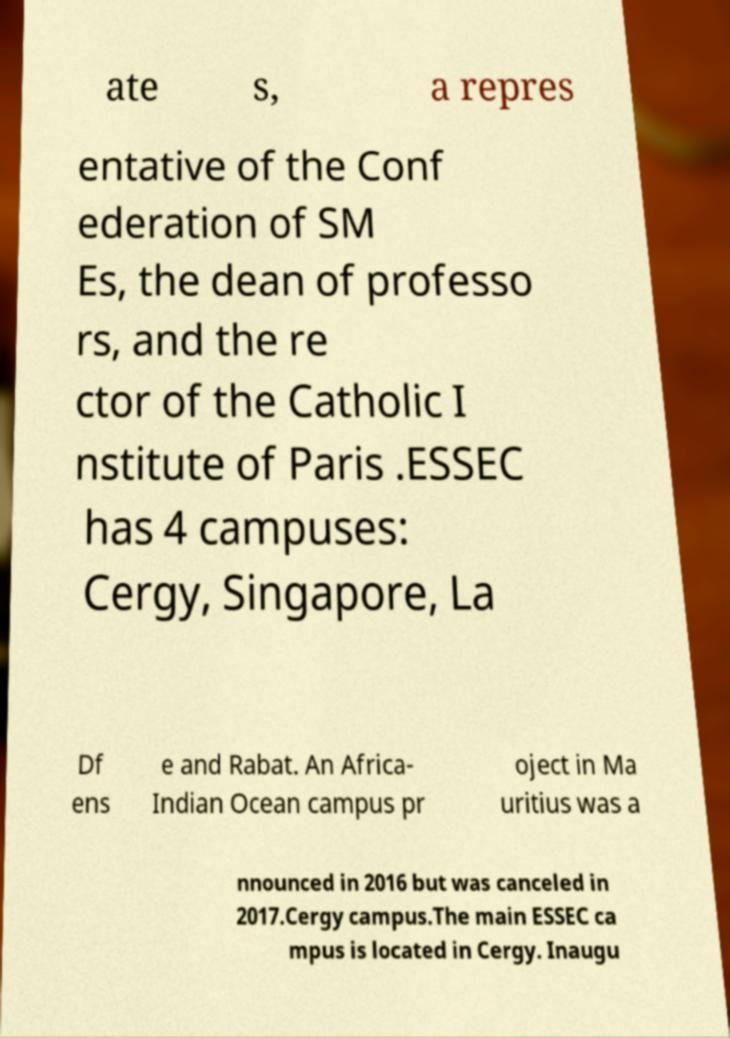For documentation purposes, I need the text within this image transcribed. Could you provide that? ate s, a repres entative of the Conf ederation of SM Es, the dean of professo rs, and the re ctor of the Catholic I nstitute of Paris .ESSEC has 4 campuses: Cergy, Singapore, La Df ens e and Rabat. An Africa- Indian Ocean campus pr oject in Ma uritius was a nnounced in 2016 but was canceled in 2017.Cergy campus.The main ESSEC ca mpus is located in Cergy. Inaugu 